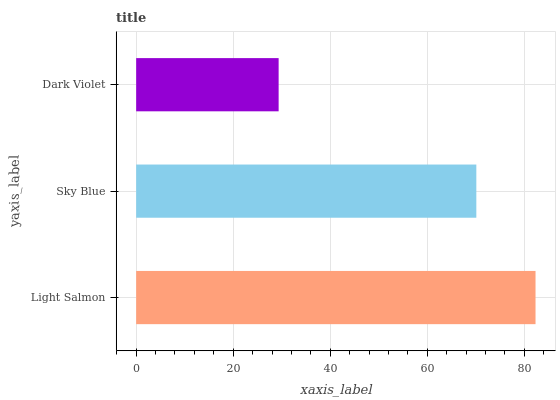Is Dark Violet the minimum?
Answer yes or no. Yes. Is Light Salmon the maximum?
Answer yes or no. Yes. Is Sky Blue the minimum?
Answer yes or no. No. Is Sky Blue the maximum?
Answer yes or no. No. Is Light Salmon greater than Sky Blue?
Answer yes or no. Yes. Is Sky Blue less than Light Salmon?
Answer yes or no. Yes. Is Sky Blue greater than Light Salmon?
Answer yes or no. No. Is Light Salmon less than Sky Blue?
Answer yes or no. No. Is Sky Blue the high median?
Answer yes or no. Yes. Is Sky Blue the low median?
Answer yes or no. Yes. Is Dark Violet the high median?
Answer yes or no. No. Is Light Salmon the low median?
Answer yes or no. No. 